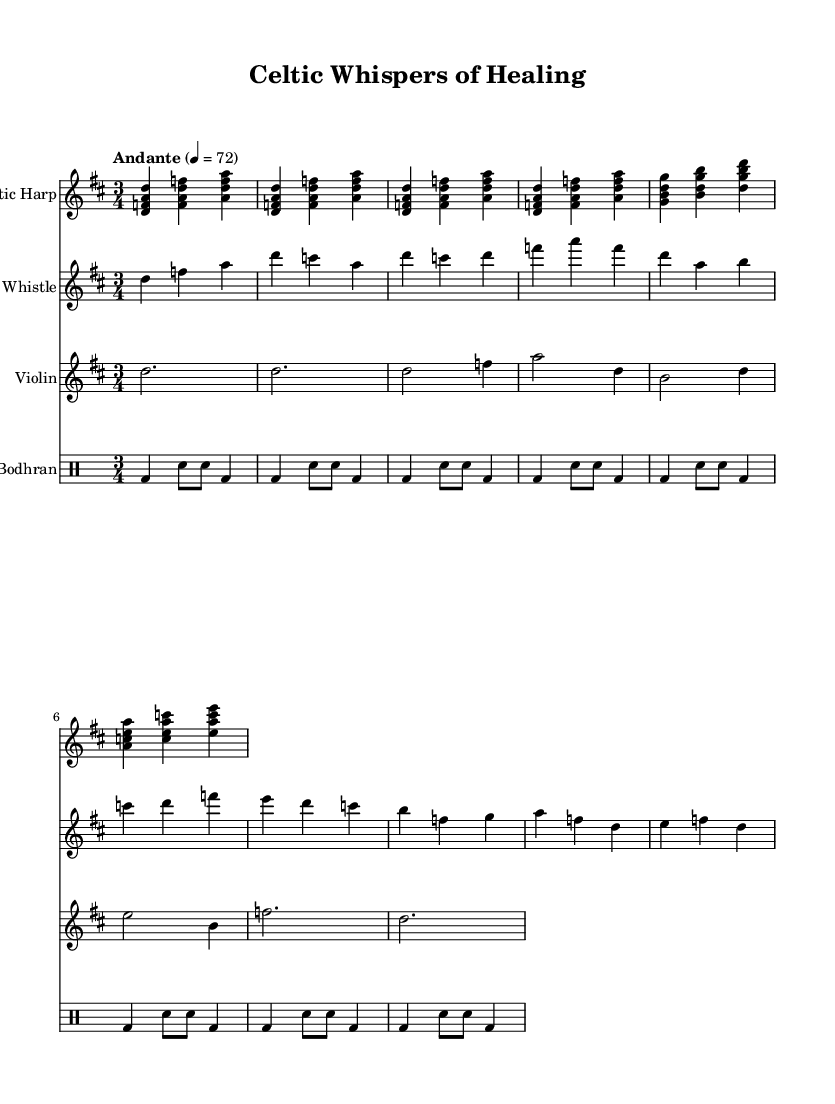What is the key signature of this music? The key signature is D major, which includes two sharps (F# and C#). You can find the key signature indicated at the beginning of the staff.
Answer: D major What is the time signature of this music? The time signature is 3/4, which is visible at the beginning of the score. It indicates that there are three beats per measure, and the quarter note gets one beat.
Answer: 3/4 What is the tempo marking of this piece? The tempo marking is "Andante," which means a moderately slow tempo. This is indicated near the beginning of the score along with a metronome marking of 72 beats per minute.
Answer: Andante How many measures are there in the A section? The A section consists of six measures total. This can be determined by counting the measures in the corresponding section indicated in the sheet music.
Answer: 6 Identify the instrument that plays the melody in the intro. The instrument that plays the melody in the intro is the Tin Whistle, as shown by the notes listed under the staff labeled "Tin Whistle" at the beginning of the piece.
Answer: Tin Whistle Which instruments are included in this piece? The instruments included are Celtic Harp, Tin Whistle, Violin, and Bodhran. You can see the staff names listed at the beginning for each respective instrument.
Answer: Celtic Harp, Tin Whistle, Violin, Bodhran What role does the Bodhran serve in this arrangement? The Bodhran serves as a percussion instrument providing rhythmic support. It typically plays a steady beat, and this can be observed through the consistent rhythmic patterns throughout its part.
Answer: Percussion 